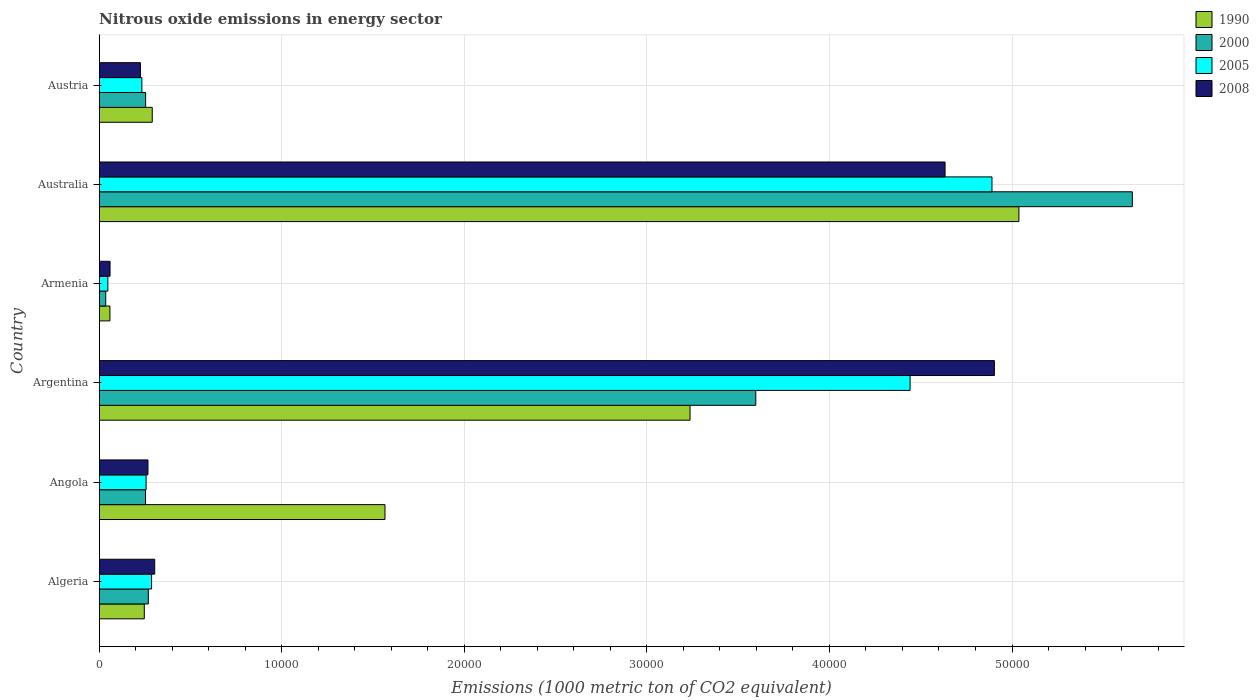How many different coloured bars are there?
Give a very brief answer. 4. How many groups of bars are there?
Your answer should be very brief. 6. Are the number of bars on each tick of the Y-axis equal?
Your answer should be compact. Yes. How many bars are there on the 6th tick from the top?
Ensure brevity in your answer.  4. In how many cases, is the number of bars for a given country not equal to the number of legend labels?
Make the answer very short. 0. What is the amount of nitrous oxide emitted in 2008 in Armenia?
Provide a succinct answer. 593.5. Across all countries, what is the maximum amount of nitrous oxide emitted in 1990?
Provide a short and direct response. 5.04e+04. Across all countries, what is the minimum amount of nitrous oxide emitted in 2008?
Provide a short and direct response. 593.5. In which country was the amount of nitrous oxide emitted in 2005 minimum?
Keep it short and to the point. Armenia. What is the total amount of nitrous oxide emitted in 1990 in the graph?
Your answer should be very brief. 1.04e+05. What is the difference between the amount of nitrous oxide emitted in 1990 in Argentina and that in Austria?
Provide a succinct answer. 2.95e+04. What is the difference between the amount of nitrous oxide emitted in 1990 in Austria and the amount of nitrous oxide emitted in 2005 in Angola?
Keep it short and to the point. 337.4. What is the average amount of nitrous oxide emitted in 1990 per country?
Ensure brevity in your answer.  1.74e+04. What is the difference between the amount of nitrous oxide emitted in 1990 and amount of nitrous oxide emitted in 2000 in Argentina?
Keep it short and to the point. -3600.5. What is the ratio of the amount of nitrous oxide emitted in 2000 in Angola to that in Argentina?
Your answer should be compact. 0.07. What is the difference between the highest and the second highest amount of nitrous oxide emitted in 2000?
Your answer should be compact. 2.06e+04. What is the difference between the highest and the lowest amount of nitrous oxide emitted in 2000?
Offer a very short reply. 5.62e+04. Is the sum of the amount of nitrous oxide emitted in 2005 in Algeria and Angola greater than the maximum amount of nitrous oxide emitted in 2000 across all countries?
Your response must be concise. No. What does the 4th bar from the top in Australia represents?
Give a very brief answer. 1990. Is it the case that in every country, the sum of the amount of nitrous oxide emitted in 2005 and amount of nitrous oxide emitted in 2008 is greater than the amount of nitrous oxide emitted in 2000?
Your answer should be compact. Yes. How many bars are there?
Provide a short and direct response. 24. Are all the bars in the graph horizontal?
Your answer should be very brief. Yes. How many countries are there in the graph?
Provide a succinct answer. 6. What is the difference between two consecutive major ticks on the X-axis?
Offer a terse response. 10000. Are the values on the major ticks of X-axis written in scientific E-notation?
Make the answer very short. No. How many legend labels are there?
Keep it short and to the point. 4. What is the title of the graph?
Your answer should be compact. Nitrous oxide emissions in energy sector. What is the label or title of the X-axis?
Your answer should be very brief. Emissions (1000 metric ton of CO2 equivalent). What is the label or title of the Y-axis?
Offer a terse response. Country. What is the Emissions (1000 metric ton of CO2 equivalent) of 1990 in Algeria?
Make the answer very short. 2469.5. What is the Emissions (1000 metric ton of CO2 equivalent) of 2000 in Algeria?
Provide a succinct answer. 2690.4. What is the Emissions (1000 metric ton of CO2 equivalent) in 2005 in Algeria?
Keep it short and to the point. 2868.2. What is the Emissions (1000 metric ton of CO2 equivalent) of 2008 in Algeria?
Keep it short and to the point. 3040.1. What is the Emissions (1000 metric ton of CO2 equivalent) in 1990 in Angola?
Keep it short and to the point. 1.57e+04. What is the Emissions (1000 metric ton of CO2 equivalent) in 2000 in Angola?
Your response must be concise. 2535.2. What is the Emissions (1000 metric ton of CO2 equivalent) in 2005 in Angola?
Your response must be concise. 2567.4. What is the Emissions (1000 metric ton of CO2 equivalent) in 2008 in Angola?
Provide a succinct answer. 2670.3. What is the Emissions (1000 metric ton of CO2 equivalent) in 1990 in Argentina?
Make the answer very short. 3.24e+04. What is the Emissions (1000 metric ton of CO2 equivalent) of 2000 in Argentina?
Make the answer very short. 3.60e+04. What is the Emissions (1000 metric ton of CO2 equivalent) of 2005 in Argentina?
Your answer should be very brief. 4.44e+04. What is the Emissions (1000 metric ton of CO2 equivalent) in 2008 in Argentina?
Provide a succinct answer. 4.90e+04. What is the Emissions (1000 metric ton of CO2 equivalent) in 1990 in Armenia?
Ensure brevity in your answer.  586.2. What is the Emissions (1000 metric ton of CO2 equivalent) in 2000 in Armenia?
Make the answer very short. 356.1. What is the Emissions (1000 metric ton of CO2 equivalent) in 2005 in Armenia?
Provide a short and direct response. 473.3. What is the Emissions (1000 metric ton of CO2 equivalent) in 2008 in Armenia?
Provide a succinct answer. 593.5. What is the Emissions (1000 metric ton of CO2 equivalent) of 1990 in Australia?
Your answer should be very brief. 5.04e+04. What is the Emissions (1000 metric ton of CO2 equivalent) in 2000 in Australia?
Provide a short and direct response. 5.66e+04. What is the Emissions (1000 metric ton of CO2 equivalent) of 2005 in Australia?
Offer a very short reply. 4.89e+04. What is the Emissions (1000 metric ton of CO2 equivalent) in 2008 in Australia?
Keep it short and to the point. 4.63e+04. What is the Emissions (1000 metric ton of CO2 equivalent) of 1990 in Austria?
Your answer should be compact. 2904.8. What is the Emissions (1000 metric ton of CO2 equivalent) of 2000 in Austria?
Provide a short and direct response. 2543.3. What is the Emissions (1000 metric ton of CO2 equivalent) of 2005 in Austria?
Your answer should be very brief. 2335.7. What is the Emissions (1000 metric ton of CO2 equivalent) of 2008 in Austria?
Provide a short and direct response. 2257.3. Across all countries, what is the maximum Emissions (1000 metric ton of CO2 equivalent) in 1990?
Offer a terse response. 5.04e+04. Across all countries, what is the maximum Emissions (1000 metric ton of CO2 equivalent) in 2000?
Keep it short and to the point. 5.66e+04. Across all countries, what is the maximum Emissions (1000 metric ton of CO2 equivalent) of 2005?
Offer a very short reply. 4.89e+04. Across all countries, what is the maximum Emissions (1000 metric ton of CO2 equivalent) of 2008?
Provide a succinct answer. 4.90e+04. Across all countries, what is the minimum Emissions (1000 metric ton of CO2 equivalent) of 1990?
Keep it short and to the point. 586.2. Across all countries, what is the minimum Emissions (1000 metric ton of CO2 equivalent) in 2000?
Give a very brief answer. 356.1. Across all countries, what is the minimum Emissions (1000 metric ton of CO2 equivalent) of 2005?
Offer a very short reply. 473.3. Across all countries, what is the minimum Emissions (1000 metric ton of CO2 equivalent) in 2008?
Keep it short and to the point. 593.5. What is the total Emissions (1000 metric ton of CO2 equivalent) of 1990 in the graph?
Your answer should be very brief. 1.04e+05. What is the total Emissions (1000 metric ton of CO2 equivalent) of 2000 in the graph?
Make the answer very short. 1.01e+05. What is the total Emissions (1000 metric ton of CO2 equivalent) of 2005 in the graph?
Your answer should be very brief. 1.02e+05. What is the total Emissions (1000 metric ton of CO2 equivalent) of 2008 in the graph?
Keep it short and to the point. 1.04e+05. What is the difference between the Emissions (1000 metric ton of CO2 equivalent) in 1990 in Algeria and that in Angola?
Your response must be concise. -1.32e+04. What is the difference between the Emissions (1000 metric ton of CO2 equivalent) in 2000 in Algeria and that in Angola?
Ensure brevity in your answer.  155.2. What is the difference between the Emissions (1000 metric ton of CO2 equivalent) in 2005 in Algeria and that in Angola?
Give a very brief answer. 300.8. What is the difference between the Emissions (1000 metric ton of CO2 equivalent) in 2008 in Algeria and that in Angola?
Your answer should be very brief. 369.8. What is the difference between the Emissions (1000 metric ton of CO2 equivalent) in 1990 in Algeria and that in Argentina?
Your answer should be compact. -2.99e+04. What is the difference between the Emissions (1000 metric ton of CO2 equivalent) in 2000 in Algeria and that in Argentina?
Your response must be concise. -3.33e+04. What is the difference between the Emissions (1000 metric ton of CO2 equivalent) in 2005 in Algeria and that in Argentina?
Provide a succinct answer. -4.15e+04. What is the difference between the Emissions (1000 metric ton of CO2 equivalent) in 2008 in Algeria and that in Argentina?
Give a very brief answer. -4.60e+04. What is the difference between the Emissions (1000 metric ton of CO2 equivalent) in 1990 in Algeria and that in Armenia?
Your response must be concise. 1883.3. What is the difference between the Emissions (1000 metric ton of CO2 equivalent) in 2000 in Algeria and that in Armenia?
Your response must be concise. 2334.3. What is the difference between the Emissions (1000 metric ton of CO2 equivalent) in 2005 in Algeria and that in Armenia?
Provide a succinct answer. 2394.9. What is the difference between the Emissions (1000 metric ton of CO2 equivalent) of 2008 in Algeria and that in Armenia?
Offer a terse response. 2446.6. What is the difference between the Emissions (1000 metric ton of CO2 equivalent) of 1990 in Algeria and that in Australia?
Offer a very short reply. -4.79e+04. What is the difference between the Emissions (1000 metric ton of CO2 equivalent) in 2000 in Algeria and that in Australia?
Your answer should be compact. -5.39e+04. What is the difference between the Emissions (1000 metric ton of CO2 equivalent) of 2005 in Algeria and that in Australia?
Make the answer very short. -4.60e+04. What is the difference between the Emissions (1000 metric ton of CO2 equivalent) in 2008 in Algeria and that in Australia?
Keep it short and to the point. -4.33e+04. What is the difference between the Emissions (1000 metric ton of CO2 equivalent) in 1990 in Algeria and that in Austria?
Your response must be concise. -435.3. What is the difference between the Emissions (1000 metric ton of CO2 equivalent) in 2000 in Algeria and that in Austria?
Provide a succinct answer. 147.1. What is the difference between the Emissions (1000 metric ton of CO2 equivalent) in 2005 in Algeria and that in Austria?
Your response must be concise. 532.5. What is the difference between the Emissions (1000 metric ton of CO2 equivalent) in 2008 in Algeria and that in Austria?
Provide a succinct answer. 782.8. What is the difference between the Emissions (1000 metric ton of CO2 equivalent) of 1990 in Angola and that in Argentina?
Keep it short and to the point. -1.67e+04. What is the difference between the Emissions (1000 metric ton of CO2 equivalent) of 2000 in Angola and that in Argentina?
Keep it short and to the point. -3.34e+04. What is the difference between the Emissions (1000 metric ton of CO2 equivalent) of 2005 in Angola and that in Argentina?
Keep it short and to the point. -4.18e+04. What is the difference between the Emissions (1000 metric ton of CO2 equivalent) of 2008 in Angola and that in Argentina?
Offer a very short reply. -4.64e+04. What is the difference between the Emissions (1000 metric ton of CO2 equivalent) in 1990 in Angola and that in Armenia?
Keep it short and to the point. 1.51e+04. What is the difference between the Emissions (1000 metric ton of CO2 equivalent) in 2000 in Angola and that in Armenia?
Ensure brevity in your answer.  2179.1. What is the difference between the Emissions (1000 metric ton of CO2 equivalent) in 2005 in Angola and that in Armenia?
Your answer should be compact. 2094.1. What is the difference between the Emissions (1000 metric ton of CO2 equivalent) of 2008 in Angola and that in Armenia?
Your answer should be compact. 2076.8. What is the difference between the Emissions (1000 metric ton of CO2 equivalent) of 1990 in Angola and that in Australia?
Keep it short and to the point. -3.47e+04. What is the difference between the Emissions (1000 metric ton of CO2 equivalent) of 2000 in Angola and that in Australia?
Provide a succinct answer. -5.41e+04. What is the difference between the Emissions (1000 metric ton of CO2 equivalent) in 2005 in Angola and that in Australia?
Your answer should be very brief. -4.63e+04. What is the difference between the Emissions (1000 metric ton of CO2 equivalent) of 2008 in Angola and that in Australia?
Ensure brevity in your answer.  -4.37e+04. What is the difference between the Emissions (1000 metric ton of CO2 equivalent) in 1990 in Angola and that in Austria?
Offer a terse response. 1.27e+04. What is the difference between the Emissions (1000 metric ton of CO2 equivalent) of 2005 in Angola and that in Austria?
Your answer should be compact. 231.7. What is the difference between the Emissions (1000 metric ton of CO2 equivalent) in 2008 in Angola and that in Austria?
Offer a very short reply. 413. What is the difference between the Emissions (1000 metric ton of CO2 equivalent) in 1990 in Argentina and that in Armenia?
Offer a terse response. 3.18e+04. What is the difference between the Emissions (1000 metric ton of CO2 equivalent) of 2000 in Argentina and that in Armenia?
Your response must be concise. 3.56e+04. What is the difference between the Emissions (1000 metric ton of CO2 equivalent) of 2005 in Argentina and that in Armenia?
Your answer should be very brief. 4.39e+04. What is the difference between the Emissions (1000 metric ton of CO2 equivalent) of 2008 in Argentina and that in Armenia?
Keep it short and to the point. 4.84e+04. What is the difference between the Emissions (1000 metric ton of CO2 equivalent) of 1990 in Argentina and that in Australia?
Keep it short and to the point. -1.80e+04. What is the difference between the Emissions (1000 metric ton of CO2 equivalent) in 2000 in Argentina and that in Australia?
Your answer should be compact. -2.06e+04. What is the difference between the Emissions (1000 metric ton of CO2 equivalent) of 2005 in Argentina and that in Australia?
Offer a very short reply. -4485.6. What is the difference between the Emissions (1000 metric ton of CO2 equivalent) in 2008 in Argentina and that in Australia?
Your answer should be compact. 2702.4. What is the difference between the Emissions (1000 metric ton of CO2 equivalent) of 1990 in Argentina and that in Austria?
Ensure brevity in your answer.  2.95e+04. What is the difference between the Emissions (1000 metric ton of CO2 equivalent) in 2000 in Argentina and that in Austria?
Give a very brief answer. 3.34e+04. What is the difference between the Emissions (1000 metric ton of CO2 equivalent) of 2005 in Argentina and that in Austria?
Offer a terse response. 4.21e+04. What is the difference between the Emissions (1000 metric ton of CO2 equivalent) of 2008 in Argentina and that in Austria?
Ensure brevity in your answer.  4.68e+04. What is the difference between the Emissions (1000 metric ton of CO2 equivalent) of 1990 in Armenia and that in Australia?
Offer a terse response. -4.98e+04. What is the difference between the Emissions (1000 metric ton of CO2 equivalent) in 2000 in Armenia and that in Australia?
Offer a terse response. -5.62e+04. What is the difference between the Emissions (1000 metric ton of CO2 equivalent) of 2005 in Armenia and that in Australia?
Your answer should be very brief. -4.84e+04. What is the difference between the Emissions (1000 metric ton of CO2 equivalent) of 2008 in Armenia and that in Australia?
Provide a short and direct response. -4.57e+04. What is the difference between the Emissions (1000 metric ton of CO2 equivalent) of 1990 in Armenia and that in Austria?
Your response must be concise. -2318.6. What is the difference between the Emissions (1000 metric ton of CO2 equivalent) of 2000 in Armenia and that in Austria?
Provide a succinct answer. -2187.2. What is the difference between the Emissions (1000 metric ton of CO2 equivalent) of 2005 in Armenia and that in Austria?
Offer a very short reply. -1862.4. What is the difference between the Emissions (1000 metric ton of CO2 equivalent) in 2008 in Armenia and that in Austria?
Give a very brief answer. -1663.8. What is the difference between the Emissions (1000 metric ton of CO2 equivalent) in 1990 in Australia and that in Austria?
Ensure brevity in your answer.  4.75e+04. What is the difference between the Emissions (1000 metric ton of CO2 equivalent) of 2000 in Australia and that in Austria?
Give a very brief answer. 5.40e+04. What is the difference between the Emissions (1000 metric ton of CO2 equivalent) of 2005 in Australia and that in Austria?
Provide a succinct answer. 4.66e+04. What is the difference between the Emissions (1000 metric ton of CO2 equivalent) in 2008 in Australia and that in Austria?
Offer a terse response. 4.41e+04. What is the difference between the Emissions (1000 metric ton of CO2 equivalent) in 1990 in Algeria and the Emissions (1000 metric ton of CO2 equivalent) in 2000 in Angola?
Offer a terse response. -65.7. What is the difference between the Emissions (1000 metric ton of CO2 equivalent) of 1990 in Algeria and the Emissions (1000 metric ton of CO2 equivalent) of 2005 in Angola?
Provide a succinct answer. -97.9. What is the difference between the Emissions (1000 metric ton of CO2 equivalent) of 1990 in Algeria and the Emissions (1000 metric ton of CO2 equivalent) of 2008 in Angola?
Provide a short and direct response. -200.8. What is the difference between the Emissions (1000 metric ton of CO2 equivalent) in 2000 in Algeria and the Emissions (1000 metric ton of CO2 equivalent) in 2005 in Angola?
Give a very brief answer. 123. What is the difference between the Emissions (1000 metric ton of CO2 equivalent) of 2000 in Algeria and the Emissions (1000 metric ton of CO2 equivalent) of 2008 in Angola?
Keep it short and to the point. 20.1. What is the difference between the Emissions (1000 metric ton of CO2 equivalent) of 2005 in Algeria and the Emissions (1000 metric ton of CO2 equivalent) of 2008 in Angola?
Keep it short and to the point. 197.9. What is the difference between the Emissions (1000 metric ton of CO2 equivalent) of 1990 in Algeria and the Emissions (1000 metric ton of CO2 equivalent) of 2000 in Argentina?
Offer a terse response. -3.35e+04. What is the difference between the Emissions (1000 metric ton of CO2 equivalent) of 1990 in Algeria and the Emissions (1000 metric ton of CO2 equivalent) of 2005 in Argentina?
Give a very brief answer. -4.19e+04. What is the difference between the Emissions (1000 metric ton of CO2 equivalent) in 1990 in Algeria and the Emissions (1000 metric ton of CO2 equivalent) in 2008 in Argentina?
Give a very brief answer. -4.66e+04. What is the difference between the Emissions (1000 metric ton of CO2 equivalent) in 2000 in Algeria and the Emissions (1000 metric ton of CO2 equivalent) in 2005 in Argentina?
Give a very brief answer. -4.17e+04. What is the difference between the Emissions (1000 metric ton of CO2 equivalent) in 2000 in Algeria and the Emissions (1000 metric ton of CO2 equivalent) in 2008 in Argentina?
Offer a very short reply. -4.63e+04. What is the difference between the Emissions (1000 metric ton of CO2 equivalent) of 2005 in Algeria and the Emissions (1000 metric ton of CO2 equivalent) of 2008 in Argentina?
Make the answer very short. -4.62e+04. What is the difference between the Emissions (1000 metric ton of CO2 equivalent) of 1990 in Algeria and the Emissions (1000 metric ton of CO2 equivalent) of 2000 in Armenia?
Your answer should be very brief. 2113.4. What is the difference between the Emissions (1000 metric ton of CO2 equivalent) of 1990 in Algeria and the Emissions (1000 metric ton of CO2 equivalent) of 2005 in Armenia?
Provide a succinct answer. 1996.2. What is the difference between the Emissions (1000 metric ton of CO2 equivalent) of 1990 in Algeria and the Emissions (1000 metric ton of CO2 equivalent) of 2008 in Armenia?
Keep it short and to the point. 1876. What is the difference between the Emissions (1000 metric ton of CO2 equivalent) of 2000 in Algeria and the Emissions (1000 metric ton of CO2 equivalent) of 2005 in Armenia?
Ensure brevity in your answer.  2217.1. What is the difference between the Emissions (1000 metric ton of CO2 equivalent) in 2000 in Algeria and the Emissions (1000 metric ton of CO2 equivalent) in 2008 in Armenia?
Provide a succinct answer. 2096.9. What is the difference between the Emissions (1000 metric ton of CO2 equivalent) in 2005 in Algeria and the Emissions (1000 metric ton of CO2 equivalent) in 2008 in Armenia?
Give a very brief answer. 2274.7. What is the difference between the Emissions (1000 metric ton of CO2 equivalent) in 1990 in Algeria and the Emissions (1000 metric ton of CO2 equivalent) in 2000 in Australia?
Ensure brevity in your answer.  -5.41e+04. What is the difference between the Emissions (1000 metric ton of CO2 equivalent) in 1990 in Algeria and the Emissions (1000 metric ton of CO2 equivalent) in 2005 in Australia?
Give a very brief answer. -4.64e+04. What is the difference between the Emissions (1000 metric ton of CO2 equivalent) of 1990 in Algeria and the Emissions (1000 metric ton of CO2 equivalent) of 2008 in Australia?
Offer a very short reply. -4.39e+04. What is the difference between the Emissions (1000 metric ton of CO2 equivalent) of 2000 in Algeria and the Emissions (1000 metric ton of CO2 equivalent) of 2005 in Australia?
Provide a short and direct response. -4.62e+04. What is the difference between the Emissions (1000 metric ton of CO2 equivalent) of 2000 in Algeria and the Emissions (1000 metric ton of CO2 equivalent) of 2008 in Australia?
Make the answer very short. -4.36e+04. What is the difference between the Emissions (1000 metric ton of CO2 equivalent) of 2005 in Algeria and the Emissions (1000 metric ton of CO2 equivalent) of 2008 in Australia?
Your answer should be compact. -4.35e+04. What is the difference between the Emissions (1000 metric ton of CO2 equivalent) in 1990 in Algeria and the Emissions (1000 metric ton of CO2 equivalent) in 2000 in Austria?
Keep it short and to the point. -73.8. What is the difference between the Emissions (1000 metric ton of CO2 equivalent) in 1990 in Algeria and the Emissions (1000 metric ton of CO2 equivalent) in 2005 in Austria?
Your answer should be compact. 133.8. What is the difference between the Emissions (1000 metric ton of CO2 equivalent) in 1990 in Algeria and the Emissions (1000 metric ton of CO2 equivalent) in 2008 in Austria?
Keep it short and to the point. 212.2. What is the difference between the Emissions (1000 metric ton of CO2 equivalent) in 2000 in Algeria and the Emissions (1000 metric ton of CO2 equivalent) in 2005 in Austria?
Make the answer very short. 354.7. What is the difference between the Emissions (1000 metric ton of CO2 equivalent) of 2000 in Algeria and the Emissions (1000 metric ton of CO2 equivalent) of 2008 in Austria?
Ensure brevity in your answer.  433.1. What is the difference between the Emissions (1000 metric ton of CO2 equivalent) of 2005 in Algeria and the Emissions (1000 metric ton of CO2 equivalent) of 2008 in Austria?
Give a very brief answer. 610.9. What is the difference between the Emissions (1000 metric ton of CO2 equivalent) in 1990 in Angola and the Emissions (1000 metric ton of CO2 equivalent) in 2000 in Argentina?
Offer a terse response. -2.03e+04. What is the difference between the Emissions (1000 metric ton of CO2 equivalent) of 1990 in Angola and the Emissions (1000 metric ton of CO2 equivalent) of 2005 in Argentina?
Your answer should be compact. -2.88e+04. What is the difference between the Emissions (1000 metric ton of CO2 equivalent) of 1990 in Angola and the Emissions (1000 metric ton of CO2 equivalent) of 2008 in Argentina?
Your answer should be very brief. -3.34e+04. What is the difference between the Emissions (1000 metric ton of CO2 equivalent) of 2000 in Angola and the Emissions (1000 metric ton of CO2 equivalent) of 2005 in Argentina?
Offer a terse response. -4.19e+04. What is the difference between the Emissions (1000 metric ton of CO2 equivalent) of 2000 in Angola and the Emissions (1000 metric ton of CO2 equivalent) of 2008 in Argentina?
Offer a terse response. -4.65e+04. What is the difference between the Emissions (1000 metric ton of CO2 equivalent) of 2005 in Angola and the Emissions (1000 metric ton of CO2 equivalent) of 2008 in Argentina?
Give a very brief answer. -4.65e+04. What is the difference between the Emissions (1000 metric ton of CO2 equivalent) of 1990 in Angola and the Emissions (1000 metric ton of CO2 equivalent) of 2000 in Armenia?
Ensure brevity in your answer.  1.53e+04. What is the difference between the Emissions (1000 metric ton of CO2 equivalent) in 1990 in Angola and the Emissions (1000 metric ton of CO2 equivalent) in 2005 in Armenia?
Ensure brevity in your answer.  1.52e+04. What is the difference between the Emissions (1000 metric ton of CO2 equivalent) in 1990 in Angola and the Emissions (1000 metric ton of CO2 equivalent) in 2008 in Armenia?
Ensure brevity in your answer.  1.51e+04. What is the difference between the Emissions (1000 metric ton of CO2 equivalent) in 2000 in Angola and the Emissions (1000 metric ton of CO2 equivalent) in 2005 in Armenia?
Your answer should be very brief. 2061.9. What is the difference between the Emissions (1000 metric ton of CO2 equivalent) in 2000 in Angola and the Emissions (1000 metric ton of CO2 equivalent) in 2008 in Armenia?
Your answer should be very brief. 1941.7. What is the difference between the Emissions (1000 metric ton of CO2 equivalent) of 2005 in Angola and the Emissions (1000 metric ton of CO2 equivalent) of 2008 in Armenia?
Give a very brief answer. 1973.9. What is the difference between the Emissions (1000 metric ton of CO2 equivalent) of 1990 in Angola and the Emissions (1000 metric ton of CO2 equivalent) of 2000 in Australia?
Offer a very short reply. -4.09e+04. What is the difference between the Emissions (1000 metric ton of CO2 equivalent) of 1990 in Angola and the Emissions (1000 metric ton of CO2 equivalent) of 2005 in Australia?
Provide a short and direct response. -3.32e+04. What is the difference between the Emissions (1000 metric ton of CO2 equivalent) in 1990 in Angola and the Emissions (1000 metric ton of CO2 equivalent) in 2008 in Australia?
Give a very brief answer. -3.07e+04. What is the difference between the Emissions (1000 metric ton of CO2 equivalent) of 2000 in Angola and the Emissions (1000 metric ton of CO2 equivalent) of 2005 in Australia?
Make the answer very short. -4.64e+04. What is the difference between the Emissions (1000 metric ton of CO2 equivalent) of 2000 in Angola and the Emissions (1000 metric ton of CO2 equivalent) of 2008 in Australia?
Make the answer very short. -4.38e+04. What is the difference between the Emissions (1000 metric ton of CO2 equivalent) of 2005 in Angola and the Emissions (1000 metric ton of CO2 equivalent) of 2008 in Australia?
Your response must be concise. -4.38e+04. What is the difference between the Emissions (1000 metric ton of CO2 equivalent) in 1990 in Angola and the Emissions (1000 metric ton of CO2 equivalent) in 2000 in Austria?
Your response must be concise. 1.31e+04. What is the difference between the Emissions (1000 metric ton of CO2 equivalent) in 1990 in Angola and the Emissions (1000 metric ton of CO2 equivalent) in 2005 in Austria?
Your response must be concise. 1.33e+04. What is the difference between the Emissions (1000 metric ton of CO2 equivalent) in 1990 in Angola and the Emissions (1000 metric ton of CO2 equivalent) in 2008 in Austria?
Give a very brief answer. 1.34e+04. What is the difference between the Emissions (1000 metric ton of CO2 equivalent) in 2000 in Angola and the Emissions (1000 metric ton of CO2 equivalent) in 2005 in Austria?
Your answer should be very brief. 199.5. What is the difference between the Emissions (1000 metric ton of CO2 equivalent) in 2000 in Angola and the Emissions (1000 metric ton of CO2 equivalent) in 2008 in Austria?
Provide a short and direct response. 277.9. What is the difference between the Emissions (1000 metric ton of CO2 equivalent) of 2005 in Angola and the Emissions (1000 metric ton of CO2 equivalent) of 2008 in Austria?
Ensure brevity in your answer.  310.1. What is the difference between the Emissions (1000 metric ton of CO2 equivalent) of 1990 in Argentina and the Emissions (1000 metric ton of CO2 equivalent) of 2000 in Armenia?
Make the answer very short. 3.20e+04. What is the difference between the Emissions (1000 metric ton of CO2 equivalent) in 1990 in Argentina and the Emissions (1000 metric ton of CO2 equivalent) in 2005 in Armenia?
Make the answer very short. 3.19e+04. What is the difference between the Emissions (1000 metric ton of CO2 equivalent) of 1990 in Argentina and the Emissions (1000 metric ton of CO2 equivalent) of 2008 in Armenia?
Ensure brevity in your answer.  3.18e+04. What is the difference between the Emissions (1000 metric ton of CO2 equivalent) of 2000 in Argentina and the Emissions (1000 metric ton of CO2 equivalent) of 2005 in Armenia?
Your response must be concise. 3.55e+04. What is the difference between the Emissions (1000 metric ton of CO2 equivalent) in 2000 in Argentina and the Emissions (1000 metric ton of CO2 equivalent) in 2008 in Armenia?
Your response must be concise. 3.54e+04. What is the difference between the Emissions (1000 metric ton of CO2 equivalent) in 2005 in Argentina and the Emissions (1000 metric ton of CO2 equivalent) in 2008 in Armenia?
Offer a very short reply. 4.38e+04. What is the difference between the Emissions (1000 metric ton of CO2 equivalent) of 1990 in Argentina and the Emissions (1000 metric ton of CO2 equivalent) of 2000 in Australia?
Provide a short and direct response. -2.42e+04. What is the difference between the Emissions (1000 metric ton of CO2 equivalent) of 1990 in Argentina and the Emissions (1000 metric ton of CO2 equivalent) of 2005 in Australia?
Your answer should be very brief. -1.65e+04. What is the difference between the Emissions (1000 metric ton of CO2 equivalent) of 1990 in Argentina and the Emissions (1000 metric ton of CO2 equivalent) of 2008 in Australia?
Offer a terse response. -1.40e+04. What is the difference between the Emissions (1000 metric ton of CO2 equivalent) of 2000 in Argentina and the Emissions (1000 metric ton of CO2 equivalent) of 2005 in Australia?
Your answer should be very brief. -1.29e+04. What is the difference between the Emissions (1000 metric ton of CO2 equivalent) in 2000 in Argentina and the Emissions (1000 metric ton of CO2 equivalent) in 2008 in Australia?
Keep it short and to the point. -1.04e+04. What is the difference between the Emissions (1000 metric ton of CO2 equivalent) of 2005 in Argentina and the Emissions (1000 metric ton of CO2 equivalent) of 2008 in Australia?
Your answer should be compact. -1915.3. What is the difference between the Emissions (1000 metric ton of CO2 equivalent) in 1990 in Argentina and the Emissions (1000 metric ton of CO2 equivalent) in 2000 in Austria?
Ensure brevity in your answer.  2.98e+04. What is the difference between the Emissions (1000 metric ton of CO2 equivalent) of 1990 in Argentina and the Emissions (1000 metric ton of CO2 equivalent) of 2005 in Austria?
Your response must be concise. 3.00e+04. What is the difference between the Emissions (1000 metric ton of CO2 equivalent) in 1990 in Argentina and the Emissions (1000 metric ton of CO2 equivalent) in 2008 in Austria?
Your response must be concise. 3.01e+04. What is the difference between the Emissions (1000 metric ton of CO2 equivalent) of 2000 in Argentina and the Emissions (1000 metric ton of CO2 equivalent) of 2005 in Austria?
Your response must be concise. 3.36e+04. What is the difference between the Emissions (1000 metric ton of CO2 equivalent) in 2000 in Argentina and the Emissions (1000 metric ton of CO2 equivalent) in 2008 in Austria?
Provide a succinct answer. 3.37e+04. What is the difference between the Emissions (1000 metric ton of CO2 equivalent) of 2005 in Argentina and the Emissions (1000 metric ton of CO2 equivalent) of 2008 in Austria?
Offer a terse response. 4.22e+04. What is the difference between the Emissions (1000 metric ton of CO2 equivalent) in 1990 in Armenia and the Emissions (1000 metric ton of CO2 equivalent) in 2000 in Australia?
Ensure brevity in your answer.  -5.60e+04. What is the difference between the Emissions (1000 metric ton of CO2 equivalent) in 1990 in Armenia and the Emissions (1000 metric ton of CO2 equivalent) in 2005 in Australia?
Your answer should be very brief. -4.83e+04. What is the difference between the Emissions (1000 metric ton of CO2 equivalent) of 1990 in Armenia and the Emissions (1000 metric ton of CO2 equivalent) of 2008 in Australia?
Provide a succinct answer. -4.57e+04. What is the difference between the Emissions (1000 metric ton of CO2 equivalent) in 2000 in Armenia and the Emissions (1000 metric ton of CO2 equivalent) in 2005 in Australia?
Offer a terse response. -4.85e+04. What is the difference between the Emissions (1000 metric ton of CO2 equivalent) of 2000 in Armenia and the Emissions (1000 metric ton of CO2 equivalent) of 2008 in Australia?
Offer a very short reply. -4.60e+04. What is the difference between the Emissions (1000 metric ton of CO2 equivalent) in 2005 in Armenia and the Emissions (1000 metric ton of CO2 equivalent) in 2008 in Australia?
Offer a terse response. -4.59e+04. What is the difference between the Emissions (1000 metric ton of CO2 equivalent) in 1990 in Armenia and the Emissions (1000 metric ton of CO2 equivalent) in 2000 in Austria?
Offer a very short reply. -1957.1. What is the difference between the Emissions (1000 metric ton of CO2 equivalent) of 1990 in Armenia and the Emissions (1000 metric ton of CO2 equivalent) of 2005 in Austria?
Ensure brevity in your answer.  -1749.5. What is the difference between the Emissions (1000 metric ton of CO2 equivalent) of 1990 in Armenia and the Emissions (1000 metric ton of CO2 equivalent) of 2008 in Austria?
Your response must be concise. -1671.1. What is the difference between the Emissions (1000 metric ton of CO2 equivalent) in 2000 in Armenia and the Emissions (1000 metric ton of CO2 equivalent) in 2005 in Austria?
Provide a succinct answer. -1979.6. What is the difference between the Emissions (1000 metric ton of CO2 equivalent) in 2000 in Armenia and the Emissions (1000 metric ton of CO2 equivalent) in 2008 in Austria?
Make the answer very short. -1901.2. What is the difference between the Emissions (1000 metric ton of CO2 equivalent) of 2005 in Armenia and the Emissions (1000 metric ton of CO2 equivalent) of 2008 in Austria?
Give a very brief answer. -1784. What is the difference between the Emissions (1000 metric ton of CO2 equivalent) of 1990 in Australia and the Emissions (1000 metric ton of CO2 equivalent) of 2000 in Austria?
Give a very brief answer. 4.78e+04. What is the difference between the Emissions (1000 metric ton of CO2 equivalent) in 1990 in Australia and the Emissions (1000 metric ton of CO2 equivalent) in 2005 in Austria?
Give a very brief answer. 4.80e+04. What is the difference between the Emissions (1000 metric ton of CO2 equivalent) of 1990 in Australia and the Emissions (1000 metric ton of CO2 equivalent) of 2008 in Austria?
Keep it short and to the point. 4.81e+04. What is the difference between the Emissions (1000 metric ton of CO2 equivalent) of 2000 in Australia and the Emissions (1000 metric ton of CO2 equivalent) of 2005 in Austria?
Provide a short and direct response. 5.43e+04. What is the difference between the Emissions (1000 metric ton of CO2 equivalent) of 2000 in Australia and the Emissions (1000 metric ton of CO2 equivalent) of 2008 in Austria?
Make the answer very short. 5.43e+04. What is the difference between the Emissions (1000 metric ton of CO2 equivalent) in 2005 in Australia and the Emissions (1000 metric ton of CO2 equivalent) in 2008 in Austria?
Give a very brief answer. 4.66e+04. What is the average Emissions (1000 metric ton of CO2 equivalent) of 1990 per country?
Make the answer very short. 1.74e+04. What is the average Emissions (1000 metric ton of CO2 equivalent) in 2000 per country?
Provide a succinct answer. 1.68e+04. What is the average Emissions (1000 metric ton of CO2 equivalent) in 2005 per country?
Your answer should be compact. 1.69e+04. What is the average Emissions (1000 metric ton of CO2 equivalent) in 2008 per country?
Provide a short and direct response. 1.73e+04. What is the difference between the Emissions (1000 metric ton of CO2 equivalent) in 1990 and Emissions (1000 metric ton of CO2 equivalent) in 2000 in Algeria?
Make the answer very short. -220.9. What is the difference between the Emissions (1000 metric ton of CO2 equivalent) of 1990 and Emissions (1000 metric ton of CO2 equivalent) of 2005 in Algeria?
Make the answer very short. -398.7. What is the difference between the Emissions (1000 metric ton of CO2 equivalent) of 1990 and Emissions (1000 metric ton of CO2 equivalent) of 2008 in Algeria?
Offer a very short reply. -570.6. What is the difference between the Emissions (1000 metric ton of CO2 equivalent) of 2000 and Emissions (1000 metric ton of CO2 equivalent) of 2005 in Algeria?
Your answer should be compact. -177.8. What is the difference between the Emissions (1000 metric ton of CO2 equivalent) in 2000 and Emissions (1000 metric ton of CO2 equivalent) in 2008 in Algeria?
Your answer should be compact. -349.7. What is the difference between the Emissions (1000 metric ton of CO2 equivalent) in 2005 and Emissions (1000 metric ton of CO2 equivalent) in 2008 in Algeria?
Offer a terse response. -171.9. What is the difference between the Emissions (1000 metric ton of CO2 equivalent) in 1990 and Emissions (1000 metric ton of CO2 equivalent) in 2000 in Angola?
Ensure brevity in your answer.  1.31e+04. What is the difference between the Emissions (1000 metric ton of CO2 equivalent) of 1990 and Emissions (1000 metric ton of CO2 equivalent) of 2005 in Angola?
Provide a short and direct response. 1.31e+04. What is the difference between the Emissions (1000 metric ton of CO2 equivalent) in 1990 and Emissions (1000 metric ton of CO2 equivalent) in 2008 in Angola?
Offer a very short reply. 1.30e+04. What is the difference between the Emissions (1000 metric ton of CO2 equivalent) in 2000 and Emissions (1000 metric ton of CO2 equivalent) in 2005 in Angola?
Ensure brevity in your answer.  -32.2. What is the difference between the Emissions (1000 metric ton of CO2 equivalent) in 2000 and Emissions (1000 metric ton of CO2 equivalent) in 2008 in Angola?
Offer a terse response. -135.1. What is the difference between the Emissions (1000 metric ton of CO2 equivalent) of 2005 and Emissions (1000 metric ton of CO2 equivalent) of 2008 in Angola?
Give a very brief answer. -102.9. What is the difference between the Emissions (1000 metric ton of CO2 equivalent) of 1990 and Emissions (1000 metric ton of CO2 equivalent) of 2000 in Argentina?
Give a very brief answer. -3600.5. What is the difference between the Emissions (1000 metric ton of CO2 equivalent) of 1990 and Emissions (1000 metric ton of CO2 equivalent) of 2005 in Argentina?
Offer a terse response. -1.21e+04. What is the difference between the Emissions (1000 metric ton of CO2 equivalent) of 1990 and Emissions (1000 metric ton of CO2 equivalent) of 2008 in Argentina?
Your answer should be compact. -1.67e+04. What is the difference between the Emissions (1000 metric ton of CO2 equivalent) of 2000 and Emissions (1000 metric ton of CO2 equivalent) of 2005 in Argentina?
Offer a terse response. -8453.1. What is the difference between the Emissions (1000 metric ton of CO2 equivalent) in 2000 and Emissions (1000 metric ton of CO2 equivalent) in 2008 in Argentina?
Your answer should be very brief. -1.31e+04. What is the difference between the Emissions (1000 metric ton of CO2 equivalent) in 2005 and Emissions (1000 metric ton of CO2 equivalent) in 2008 in Argentina?
Give a very brief answer. -4617.7. What is the difference between the Emissions (1000 metric ton of CO2 equivalent) of 1990 and Emissions (1000 metric ton of CO2 equivalent) of 2000 in Armenia?
Keep it short and to the point. 230.1. What is the difference between the Emissions (1000 metric ton of CO2 equivalent) of 1990 and Emissions (1000 metric ton of CO2 equivalent) of 2005 in Armenia?
Provide a short and direct response. 112.9. What is the difference between the Emissions (1000 metric ton of CO2 equivalent) in 2000 and Emissions (1000 metric ton of CO2 equivalent) in 2005 in Armenia?
Your answer should be very brief. -117.2. What is the difference between the Emissions (1000 metric ton of CO2 equivalent) in 2000 and Emissions (1000 metric ton of CO2 equivalent) in 2008 in Armenia?
Your answer should be very brief. -237.4. What is the difference between the Emissions (1000 metric ton of CO2 equivalent) of 2005 and Emissions (1000 metric ton of CO2 equivalent) of 2008 in Armenia?
Make the answer very short. -120.2. What is the difference between the Emissions (1000 metric ton of CO2 equivalent) in 1990 and Emissions (1000 metric ton of CO2 equivalent) in 2000 in Australia?
Your response must be concise. -6212.8. What is the difference between the Emissions (1000 metric ton of CO2 equivalent) in 1990 and Emissions (1000 metric ton of CO2 equivalent) in 2005 in Australia?
Make the answer very short. 1475.2. What is the difference between the Emissions (1000 metric ton of CO2 equivalent) in 1990 and Emissions (1000 metric ton of CO2 equivalent) in 2008 in Australia?
Provide a short and direct response. 4045.5. What is the difference between the Emissions (1000 metric ton of CO2 equivalent) in 2000 and Emissions (1000 metric ton of CO2 equivalent) in 2005 in Australia?
Give a very brief answer. 7688. What is the difference between the Emissions (1000 metric ton of CO2 equivalent) in 2000 and Emissions (1000 metric ton of CO2 equivalent) in 2008 in Australia?
Offer a very short reply. 1.03e+04. What is the difference between the Emissions (1000 metric ton of CO2 equivalent) in 2005 and Emissions (1000 metric ton of CO2 equivalent) in 2008 in Australia?
Provide a succinct answer. 2570.3. What is the difference between the Emissions (1000 metric ton of CO2 equivalent) of 1990 and Emissions (1000 metric ton of CO2 equivalent) of 2000 in Austria?
Make the answer very short. 361.5. What is the difference between the Emissions (1000 metric ton of CO2 equivalent) in 1990 and Emissions (1000 metric ton of CO2 equivalent) in 2005 in Austria?
Ensure brevity in your answer.  569.1. What is the difference between the Emissions (1000 metric ton of CO2 equivalent) of 1990 and Emissions (1000 metric ton of CO2 equivalent) of 2008 in Austria?
Provide a short and direct response. 647.5. What is the difference between the Emissions (1000 metric ton of CO2 equivalent) of 2000 and Emissions (1000 metric ton of CO2 equivalent) of 2005 in Austria?
Your response must be concise. 207.6. What is the difference between the Emissions (1000 metric ton of CO2 equivalent) of 2000 and Emissions (1000 metric ton of CO2 equivalent) of 2008 in Austria?
Make the answer very short. 286. What is the difference between the Emissions (1000 metric ton of CO2 equivalent) in 2005 and Emissions (1000 metric ton of CO2 equivalent) in 2008 in Austria?
Offer a terse response. 78.4. What is the ratio of the Emissions (1000 metric ton of CO2 equivalent) in 1990 in Algeria to that in Angola?
Your response must be concise. 0.16. What is the ratio of the Emissions (1000 metric ton of CO2 equivalent) of 2000 in Algeria to that in Angola?
Your response must be concise. 1.06. What is the ratio of the Emissions (1000 metric ton of CO2 equivalent) of 2005 in Algeria to that in Angola?
Provide a short and direct response. 1.12. What is the ratio of the Emissions (1000 metric ton of CO2 equivalent) in 2008 in Algeria to that in Angola?
Offer a terse response. 1.14. What is the ratio of the Emissions (1000 metric ton of CO2 equivalent) in 1990 in Algeria to that in Argentina?
Give a very brief answer. 0.08. What is the ratio of the Emissions (1000 metric ton of CO2 equivalent) of 2000 in Algeria to that in Argentina?
Keep it short and to the point. 0.07. What is the ratio of the Emissions (1000 metric ton of CO2 equivalent) in 2005 in Algeria to that in Argentina?
Your response must be concise. 0.06. What is the ratio of the Emissions (1000 metric ton of CO2 equivalent) in 2008 in Algeria to that in Argentina?
Offer a terse response. 0.06. What is the ratio of the Emissions (1000 metric ton of CO2 equivalent) of 1990 in Algeria to that in Armenia?
Make the answer very short. 4.21. What is the ratio of the Emissions (1000 metric ton of CO2 equivalent) of 2000 in Algeria to that in Armenia?
Ensure brevity in your answer.  7.56. What is the ratio of the Emissions (1000 metric ton of CO2 equivalent) in 2005 in Algeria to that in Armenia?
Ensure brevity in your answer.  6.06. What is the ratio of the Emissions (1000 metric ton of CO2 equivalent) of 2008 in Algeria to that in Armenia?
Your answer should be very brief. 5.12. What is the ratio of the Emissions (1000 metric ton of CO2 equivalent) of 1990 in Algeria to that in Australia?
Your answer should be very brief. 0.05. What is the ratio of the Emissions (1000 metric ton of CO2 equivalent) in 2000 in Algeria to that in Australia?
Ensure brevity in your answer.  0.05. What is the ratio of the Emissions (1000 metric ton of CO2 equivalent) in 2005 in Algeria to that in Australia?
Your response must be concise. 0.06. What is the ratio of the Emissions (1000 metric ton of CO2 equivalent) of 2008 in Algeria to that in Australia?
Keep it short and to the point. 0.07. What is the ratio of the Emissions (1000 metric ton of CO2 equivalent) of 1990 in Algeria to that in Austria?
Offer a terse response. 0.85. What is the ratio of the Emissions (1000 metric ton of CO2 equivalent) of 2000 in Algeria to that in Austria?
Your answer should be very brief. 1.06. What is the ratio of the Emissions (1000 metric ton of CO2 equivalent) in 2005 in Algeria to that in Austria?
Give a very brief answer. 1.23. What is the ratio of the Emissions (1000 metric ton of CO2 equivalent) of 2008 in Algeria to that in Austria?
Provide a succinct answer. 1.35. What is the ratio of the Emissions (1000 metric ton of CO2 equivalent) in 1990 in Angola to that in Argentina?
Your answer should be compact. 0.48. What is the ratio of the Emissions (1000 metric ton of CO2 equivalent) of 2000 in Angola to that in Argentina?
Provide a short and direct response. 0.07. What is the ratio of the Emissions (1000 metric ton of CO2 equivalent) of 2005 in Angola to that in Argentina?
Make the answer very short. 0.06. What is the ratio of the Emissions (1000 metric ton of CO2 equivalent) in 2008 in Angola to that in Argentina?
Your answer should be very brief. 0.05. What is the ratio of the Emissions (1000 metric ton of CO2 equivalent) in 1990 in Angola to that in Armenia?
Provide a short and direct response. 26.7. What is the ratio of the Emissions (1000 metric ton of CO2 equivalent) of 2000 in Angola to that in Armenia?
Offer a terse response. 7.12. What is the ratio of the Emissions (1000 metric ton of CO2 equivalent) of 2005 in Angola to that in Armenia?
Give a very brief answer. 5.42. What is the ratio of the Emissions (1000 metric ton of CO2 equivalent) of 2008 in Angola to that in Armenia?
Keep it short and to the point. 4.5. What is the ratio of the Emissions (1000 metric ton of CO2 equivalent) in 1990 in Angola to that in Australia?
Provide a short and direct response. 0.31. What is the ratio of the Emissions (1000 metric ton of CO2 equivalent) of 2000 in Angola to that in Australia?
Your response must be concise. 0.04. What is the ratio of the Emissions (1000 metric ton of CO2 equivalent) of 2005 in Angola to that in Australia?
Ensure brevity in your answer.  0.05. What is the ratio of the Emissions (1000 metric ton of CO2 equivalent) of 2008 in Angola to that in Australia?
Make the answer very short. 0.06. What is the ratio of the Emissions (1000 metric ton of CO2 equivalent) in 1990 in Angola to that in Austria?
Your response must be concise. 5.39. What is the ratio of the Emissions (1000 metric ton of CO2 equivalent) in 2005 in Angola to that in Austria?
Provide a short and direct response. 1.1. What is the ratio of the Emissions (1000 metric ton of CO2 equivalent) of 2008 in Angola to that in Austria?
Offer a very short reply. 1.18. What is the ratio of the Emissions (1000 metric ton of CO2 equivalent) in 1990 in Argentina to that in Armenia?
Offer a terse response. 55.21. What is the ratio of the Emissions (1000 metric ton of CO2 equivalent) of 2000 in Argentina to that in Armenia?
Ensure brevity in your answer.  100.99. What is the ratio of the Emissions (1000 metric ton of CO2 equivalent) of 2005 in Argentina to that in Armenia?
Your answer should be very brief. 93.85. What is the ratio of the Emissions (1000 metric ton of CO2 equivalent) in 2008 in Argentina to that in Armenia?
Offer a terse response. 82.62. What is the ratio of the Emissions (1000 metric ton of CO2 equivalent) in 1990 in Argentina to that in Australia?
Your answer should be very brief. 0.64. What is the ratio of the Emissions (1000 metric ton of CO2 equivalent) in 2000 in Argentina to that in Australia?
Your answer should be very brief. 0.64. What is the ratio of the Emissions (1000 metric ton of CO2 equivalent) in 2005 in Argentina to that in Australia?
Give a very brief answer. 0.91. What is the ratio of the Emissions (1000 metric ton of CO2 equivalent) in 2008 in Argentina to that in Australia?
Your answer should be very brief. 1.06. What is the ratio of the Emissions (1000 metric ton of CO2 equivalent) in 1990 in Argentina to that in Austria?
Your answer should be compact. 11.14. What is the ratio of the Emissions (1000 metric ton of CO2 equivalent) in 2000 in Argentina to that in Austria?
Provide a short and direct response. 14.14. What is the ratio of the Emissions (1000 metric ton of CO2 equivalent) in 2005 in Argentina to that in Austria?
Offer a very short reply. 19.02. What is the ratio of the Emissions (1000 metric ton of CO2 equivalent) of 2008 in Argentina to that in Austria?
Your response must be concise. 21.72. What is the ratio of the Emissions (1000 metric ton of CO2 equivalent) in 1990 in Armenia to that in Australia?
Your answer should be very brief. 0.01. What is the ratio of the Emissions (1000 metric ton of CO2 equivalent) of 2000 in Armenia to that in Australia?
Your response must be concise. 0.01. What is the ratio of the Emissions (1000 metric ton of CO2 equivalent) in 2005 in Armenia to that in Australia?
Provide a succinct answer. 0.01. What is the ratio of the Emissions (1000 metric ton of CO2 equivalent) of 2008 in Armenia to that in Australia?
Your answer should be very brief. 0.01. What is the ratio of the Emissions (1000 metric ton of CO2 equivalent) in 1990 in Armenia to that in Austria?
Ensure brevity in your answer.  0.2. What is the ratio of the Emissions (1000 metric ton of CO2 equivalent) in 2000 in Armenia to that in Austria?
Your answer should be compact. 0.14. What is the ratio of the Emissions (1000 metric ton of CO2 equivalent) of 2005 in Armenia to that in Austria?
Offer a very short reply. 0.2. What is the ratio of the Emissions (1000 metric ton of CO2 equivalent) of 2008 in Armenia to that in Austria?
Provide a short and direct response. 0.26. What is the ratio of the Emissions (1000 metric ton of CO2 equivalent) of 1990 in Australia to that in Austria?
Your answer should be very brief. 17.34. What is the ratio of the Emissions (1000 metric ton of CO2 equivalent) of 2000 in Australia to that in Austria?
Give a very brief answer. 22.25. What is the ratio of the Emissions (1000 metric ton of CO2 equivalent) of 2005 in Australia to that in Austria?
Your answer should be very brief. 20.94. What is the ratio of the Emissions (1000 metric ton of CO2 equivalent) of 2008 in Australia to that in Austria?
Keep it short and to the point. 20.53. What is the difference between the highest and the second highest Emissions (1000 metric ton of CO2 equivalent) of 1990?
Offer a very short reply. 1.80e+04. What is the difference between the highest and the second highest Emissions (1000 metric ton of CO2 equivalent) in 2000?
Your response must be concise. 2.06e+04. What is the difference between the highest and the second highest Emissions (1000 metric ton of CO2 equivalent) in 2005?
Ensure brevity in your answer.  4485.6. What is the difference between the highest and the second highest Emissions (1000 metric ton of CO2 equivalent) of 2008?
Your answer should be very brief. 2702.4. What is the difference between the highest and the lowest Emissions (1000 metric ton of CO2 equivalent) of 1990?
Your response must be concise. 4.98e+04. What is the difference between the highest and the lowest Emissions (1000 metric ton of CO2 equivalent) of 2000?
Your answer should be compact. 5.62e+04. What is the difference between the highest and the lowest Emissions (1000 metric ton of CO2 equivalent) of 2005?
Keep it short and to the point. 4.84e+04. What is the difference between the highest and the lowest Emissions (1000 metric ton of CO2 equivalent) in 2008?
Provide a succinct answer. 4.84e+04. 